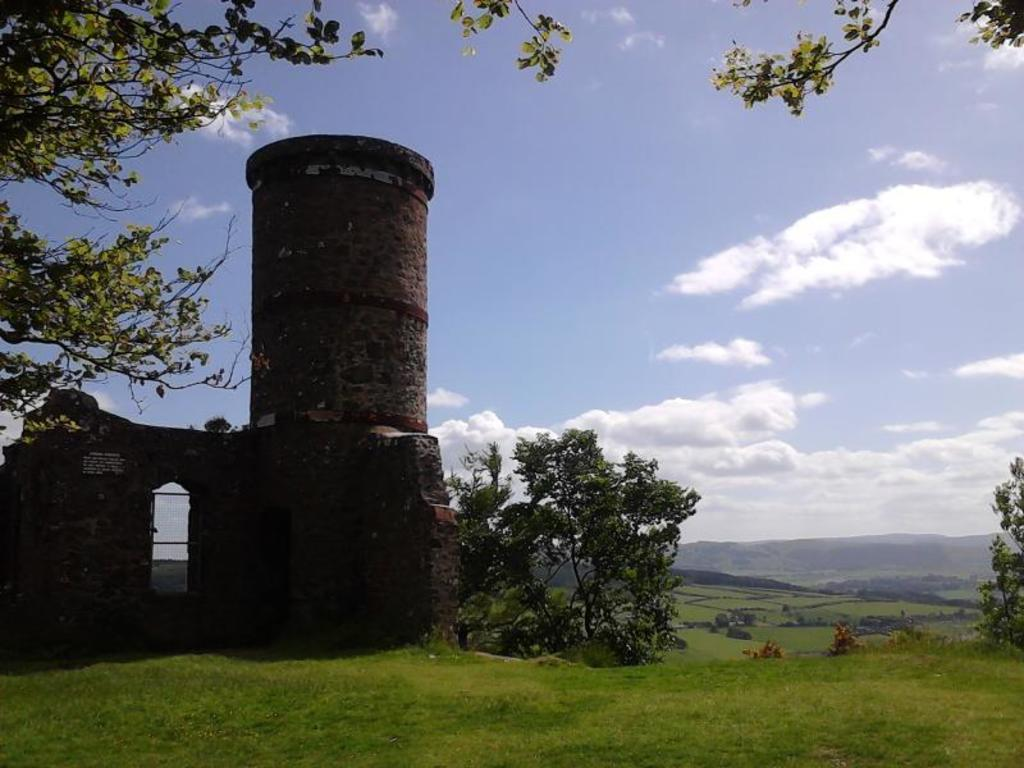What type of structure can be seen in the image? There is a building in the image. What natural elements are present in the image? There are trees, mountains, and grass visible in the image. What is visible in the background of the image? The sky is visible in the background of the image. What can be seen in the sky? Clouds are present in the sky. What type of crack can be seen in the image? There is no crack present in the image. What shape is the circle in the image? There is no circle present in the image. 